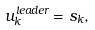<formula> <loc_0><loc_0><loc_500><loc_500>u _ { k } ^ { l e a d e r } = s _ { k } ,</formula> 